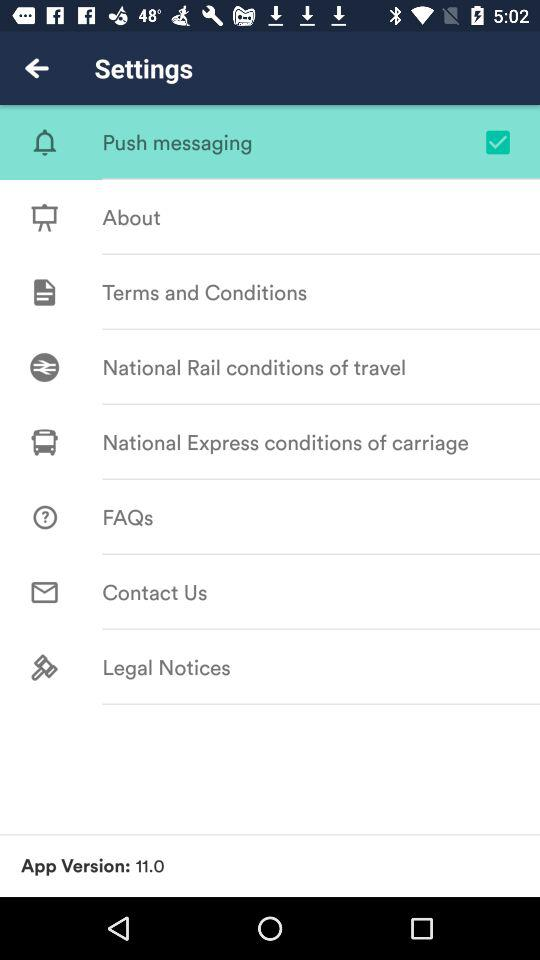How many days after today is the selected departure date?
Answer the question using a single word or phrase. 0 